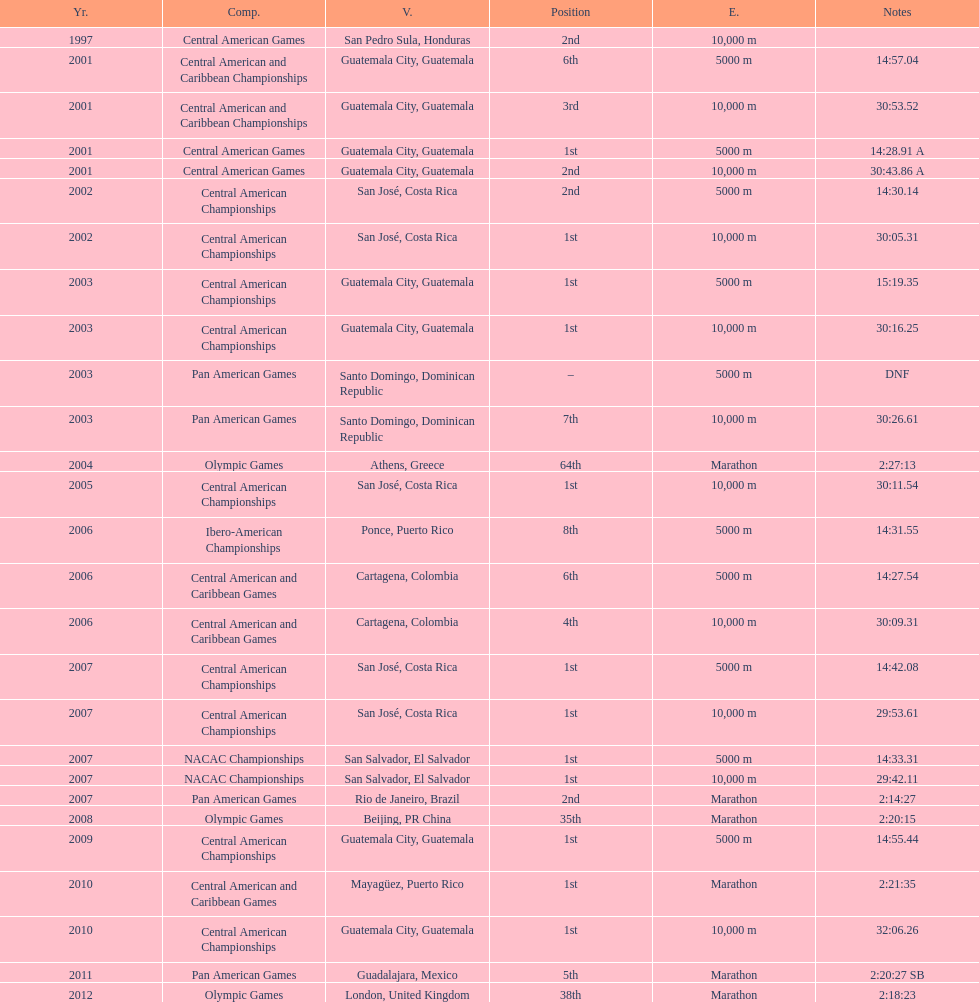The central american championships and what other competition occurred in 2010? Central American and Caribbean Games. 